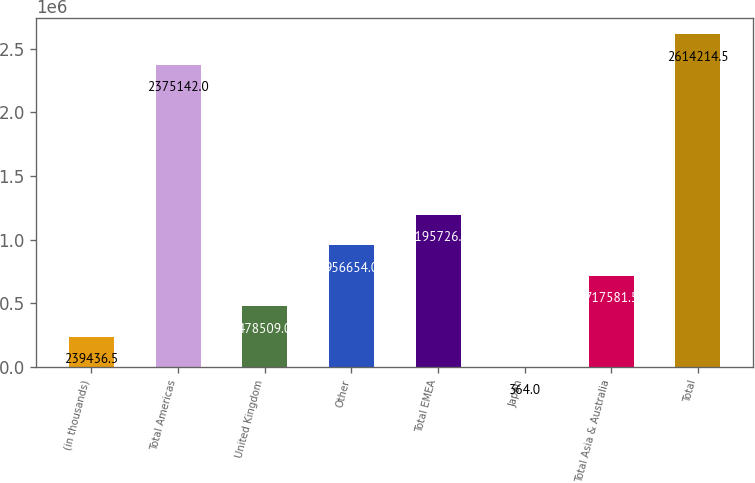Convert chart. <chart><loc_0><loc_0><loc_500><loc_500><bar_chart><fcel>(in thousands)<fcel>Total Americas<fcel>United Kingdom<fcel>Other<fcel>Total EMEA<fcel>Japan<fcel>Total Asia & Australia<fcel>Total<nl><fcel>239436<fcel>2.37514e+06<fcel>478509<fcel>956654<fcel>1.19573e+06<fcel>364<fcel>717582<fcel>2.61421e+06<nl></chart> 